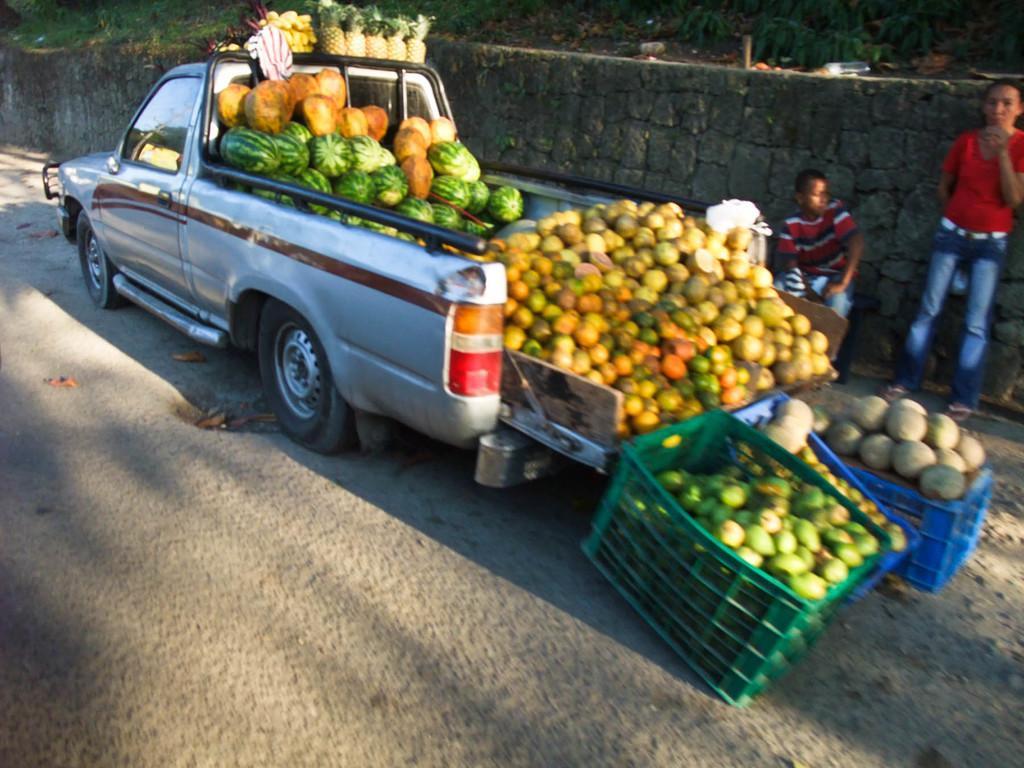Can you describe this image briefly? In this image there is one vehicle, and in the vehicle there are some fruits. And at the bottom there is walkway, and on the right side of the image there are two baskets. And in the baskets there are fruits, and in the background there are two people standing and there is a wall some plants and some objects. 